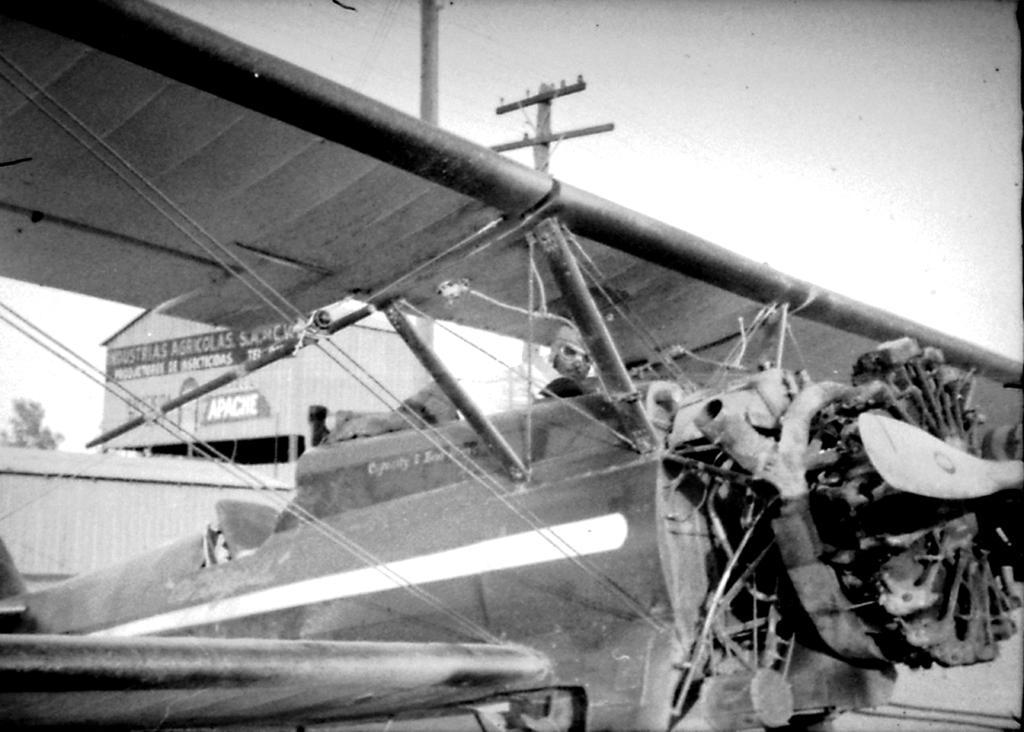Could you give a brief overview of what you see in this image? This is a black and white image. In this image, we can see a vehicle, on that vehicle, we can see a person. On the left side, we can see two electrical boxes, electric pole, electric wires. At the top, we can see a sky. 